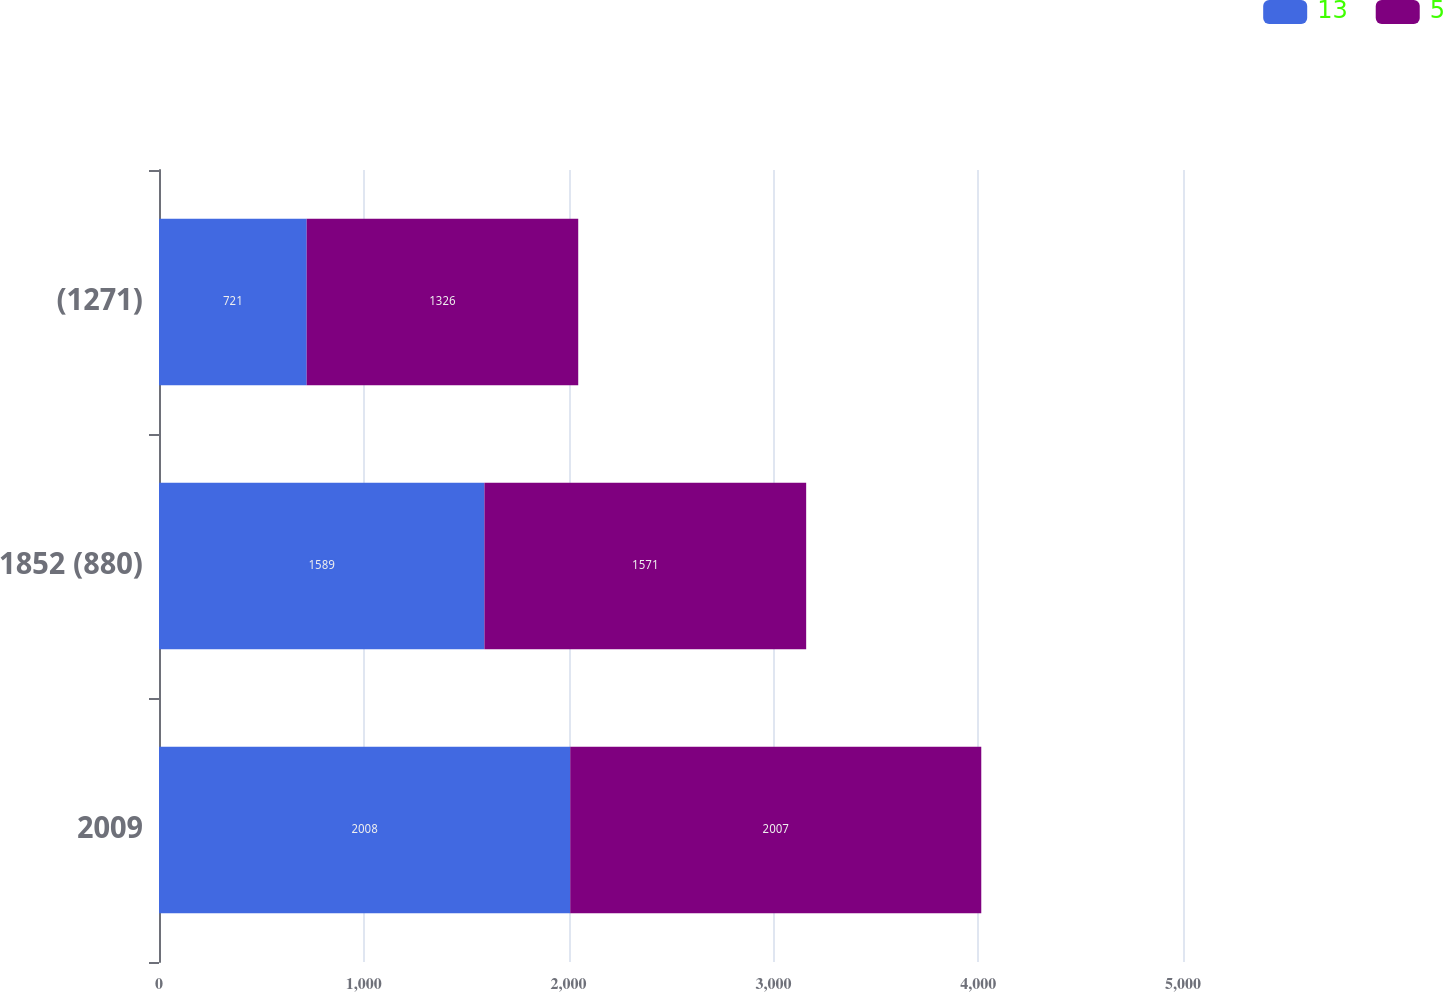Convert chart. <chart><loc_0><loc_0><loc_500><loc_500><stacked_bar_chart><ecel><fcel>2009<fcel>1852 (880)<fcel>(1271)<nl><fcel>13<fcel>2008<fcel>1589<fcel>721<nl><fcel>5<fcel>2007<fcel>1571<fcel>1326<nl></chart> 